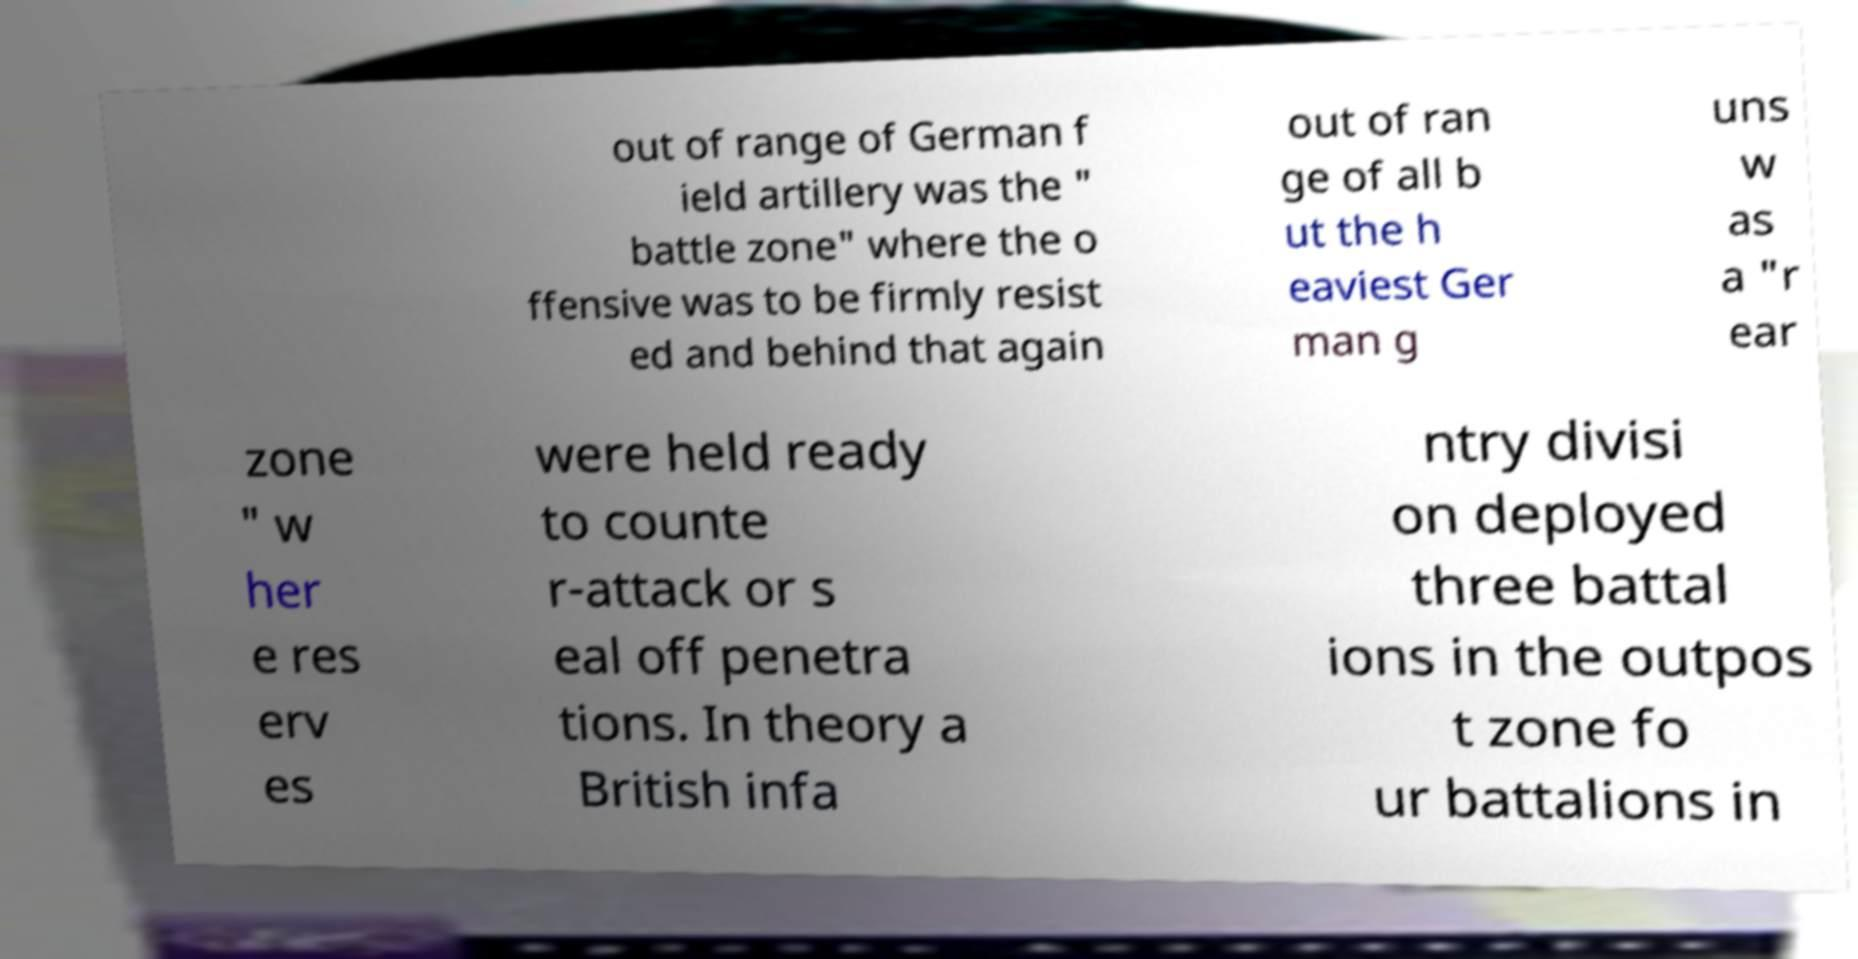Can you read and provide the text displayed in the image?This photo seems to have some interesting text. Can you extract and type it out for me? out of range of German f ield artillery was the " battle zone" where the o ffensive was to be firmly resist ed and behind that again out of ran ge of all b ut the h eaviest Ger man g uns w as a "r ear zone " w her e res erv es were held ready to counte r-attack or s eal off penetra tions. In theory a British infa ntry divisi on deployed three battal ions in the outpos t zone fo ur battalions in 